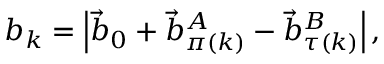Convert formula to latex. <formula><loc_0><loc_0><loc_500><loc_500>b _ { k } = \left | \vec { b } _ { 0 } + \vec { b } _ { \pi ( k ) } ^ { A } - \vec { b } _ { \tau ( k ) } ^ { B } \right | ,</formula> 